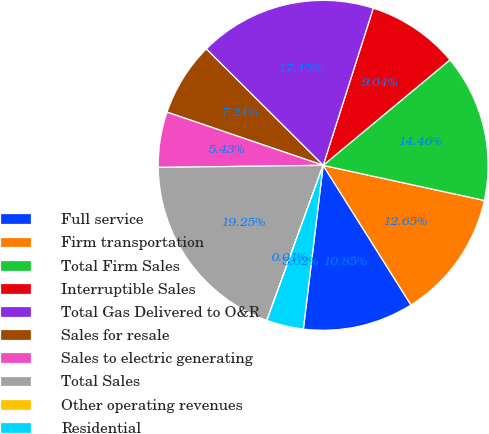Convert chart to OTSL. <chart><loc_0><loc_0><loc_500><loc_500><pie_chart><fcel>Full service<fcel>Firm transportation<fcel>Total Firm Sales<fcel>Interruptible Sales<fcel>Total Gas Delivered to O&R<fcel>Sales for resale<fcel>Sales to electric generating<fcel>Total Sales<fcel>Other operating revenues<fcel>Residential<nl><fcel>10.85%<fcel>12.65%<fcel>14.46%<fcel>9.04%<fcel>17.45%<fcel>7.24%<fcel>5.43%<fcel>19.25%<fcel>0.01%<fcel>3.62%<nl></chart> 